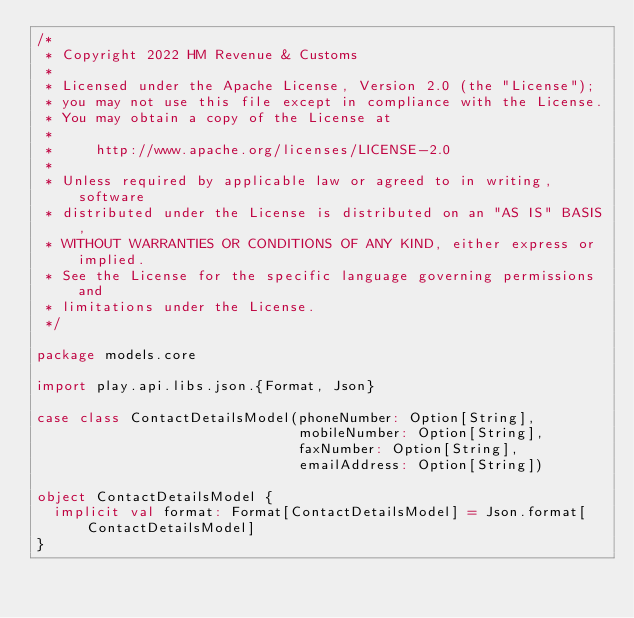<code> <loc_0><loc_0><loc_500><loc_500><_Scala_>/*
 * Copyright 2022 HM Revenue & Customs
 *
 * Licensed under the Apache License, Version 2.0 (the "License");
 * you may not use this file except in compliance with the License.
 * You may obtain a copy of the License at
 *
 *     http://www.apache.org/licenses/LICENSE-2.0
 *
 * Unless required by applicable law or agreed to in writing, software
 * distributed under the License is distributed on an "AS IS" BASIS,
 * WITHOUT WARRANTIES OR CONDITIONS OF ANY KIND, either express or implied.
 * See the License for the specific language governing permissions and
 * limitations under the License.
 */

package models.core

import play.api.libs.json.{Format, Json}

case class ContactDetailsModel(phoneNumber: Option[String],
                               mobileNumber: Option[String],
                               faxNumber: Option[String],
                               emailAddress: Option[String])

object ContactDetailsModel {
  implicit val format: Format[ContactDetailsModel] = Json.format[ContactDetailsModel]
}
</code> 